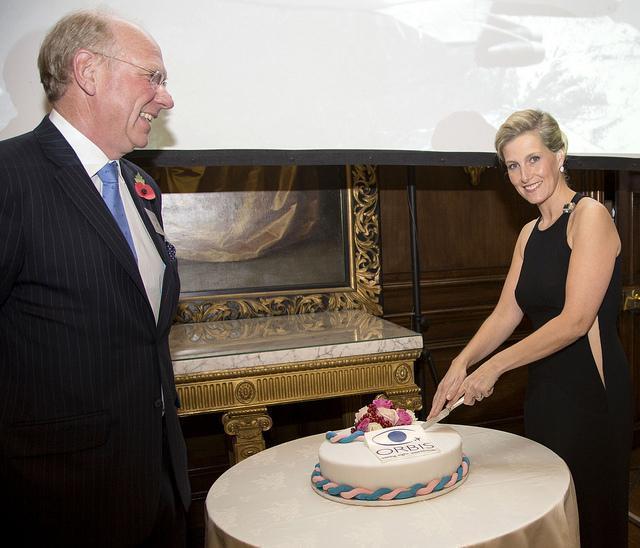What is the name of the red flower on the man's lapel?
Pick the correct solution from the four options below to address the question.
Options: Rose, poppy, daisy, chrysanthemum. Poppy. 